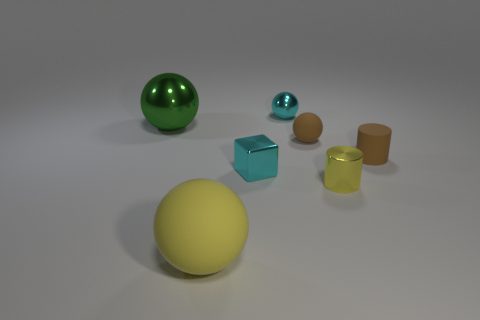Subtract 1 balls. How many balls are left? 3 Add 1 rubber objects. How many objects exist? 8 Subtract all cubes. How many objects are left? 6 Subtract all brown rubber things. Subtract all rubber cylinders. How many objects are left? 4 Add 3 metal things. How many metal things are left? 7 Add 2 tiny matte objects. How many tiny matte objects exist? 4 Subtract 1 cyan blocks. How many objects are left? 6 